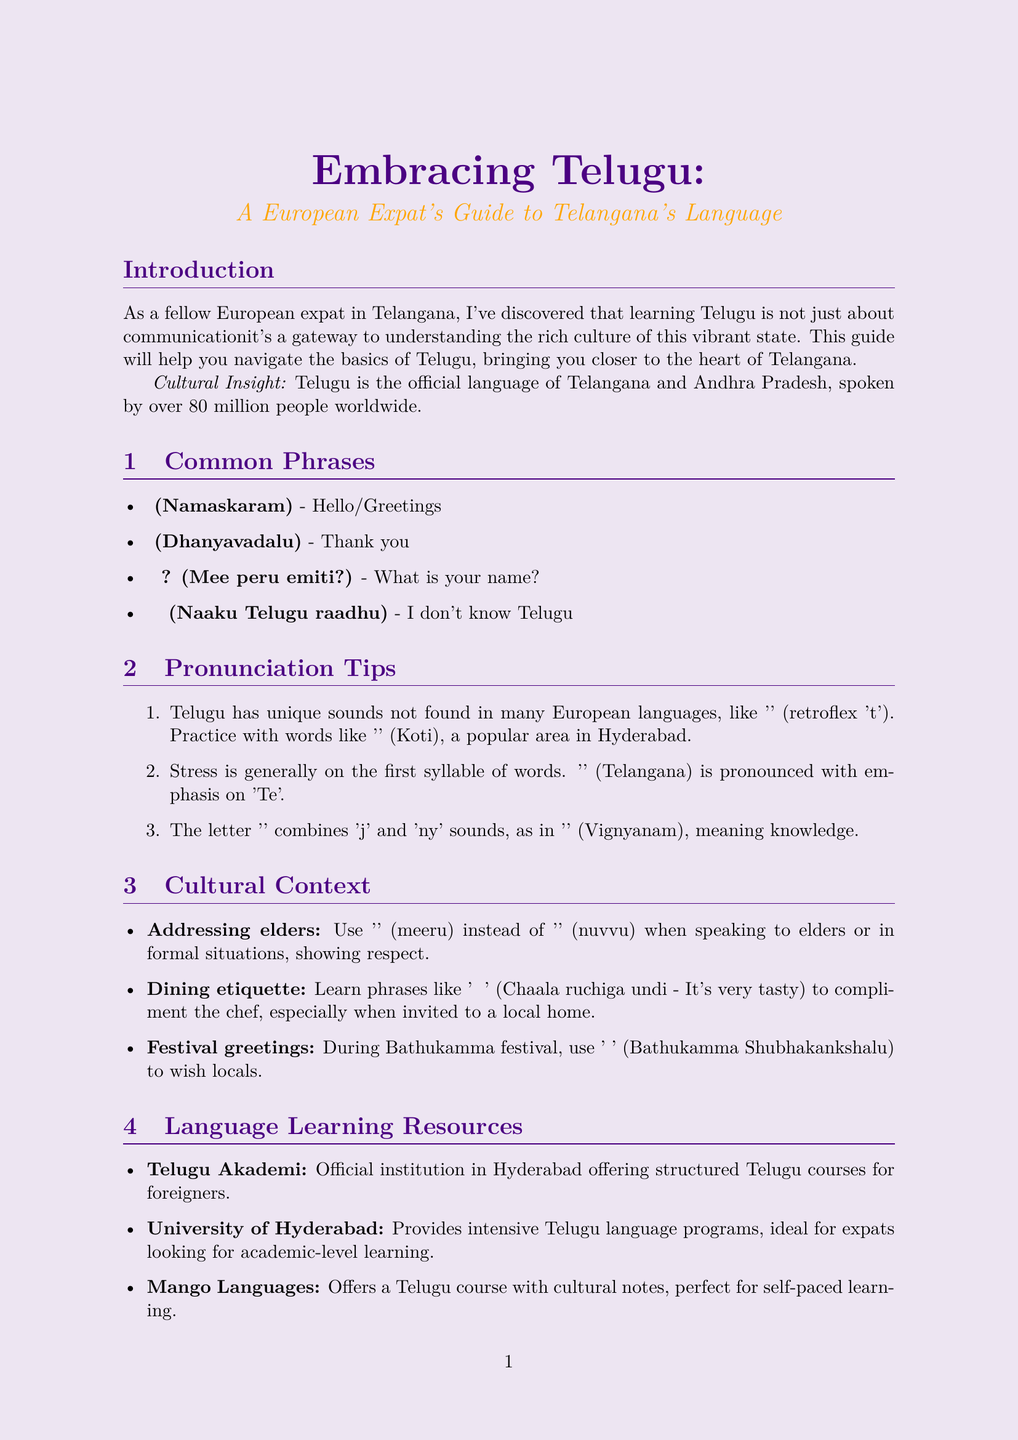What is the title of the newsletter? The title of the newsletter is presented at the beginning of the document.
Answer: Embracing Telugu: A European Expat's Guide to Telangana's Language How many people speak Telugu worldwide? This information is provided in the introduction section of the document.
Answer: over 80 million What is the Telugu phrase for 'Thank you'? The document contains a section on common phrases with their translations.
Answer: ధన్యవాదాలు (Dhanyavadalu) Which institution offers structured Telugu courses for foreigners? The document lists language learning resources, including the Telugu Akademi.
Answer: Telugu Akademi What is the proper way to address elders in Telugu? The cultural context section explains respectful language use when addressing elders.
Answer: మీరు (meeru) During which festival should you use the phrase related to Bathukamma? The cultural context section mentions a specific festival associated with a greeting.
Answer: Bathukamma What is emphasized when pronouncing 'తెలంగాణ'? The pronunciation tips detail how the stress is placed on syllables in words.
Answer: first syllable Which app provides a Telugu course with cultural notes? The language learning resources section lists various platforms and their features.
Answer: Mango Languages What is the recommended phrase to compliment food in a local home? The dining etiquette portion suggests useful phrases for social situations.
Answer: చాలా రుచిగా ఉంది (Chaala ruchiga undi - It's very tasty) 